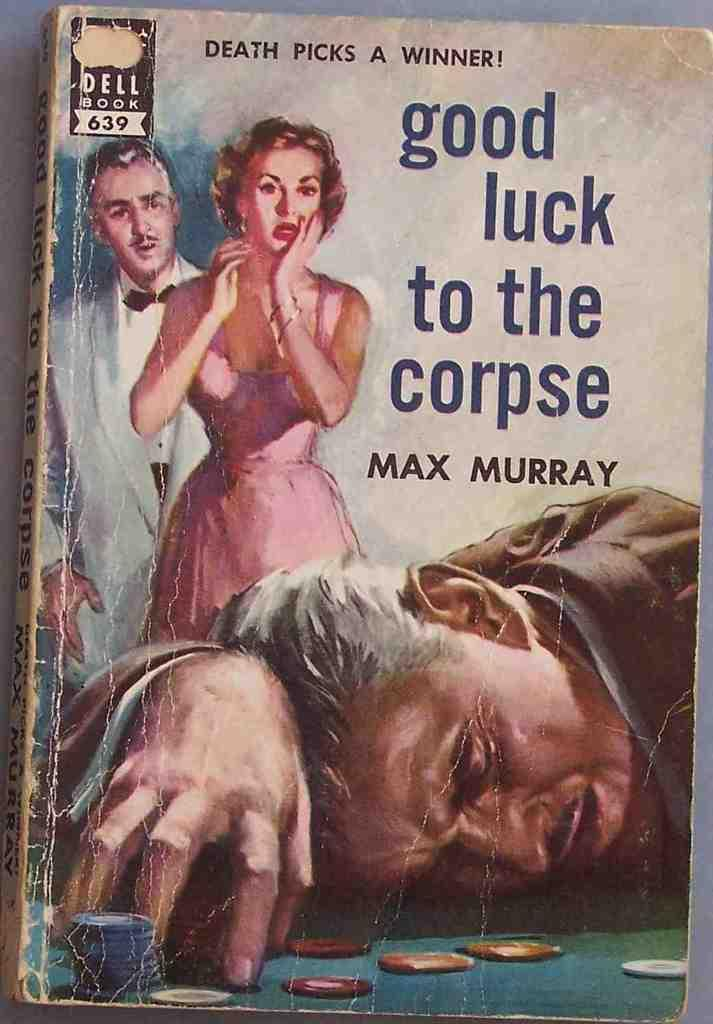<image>
Present a compact description of the photo's key features. A book titles Good Luck to the Corpse by Max Murray. 